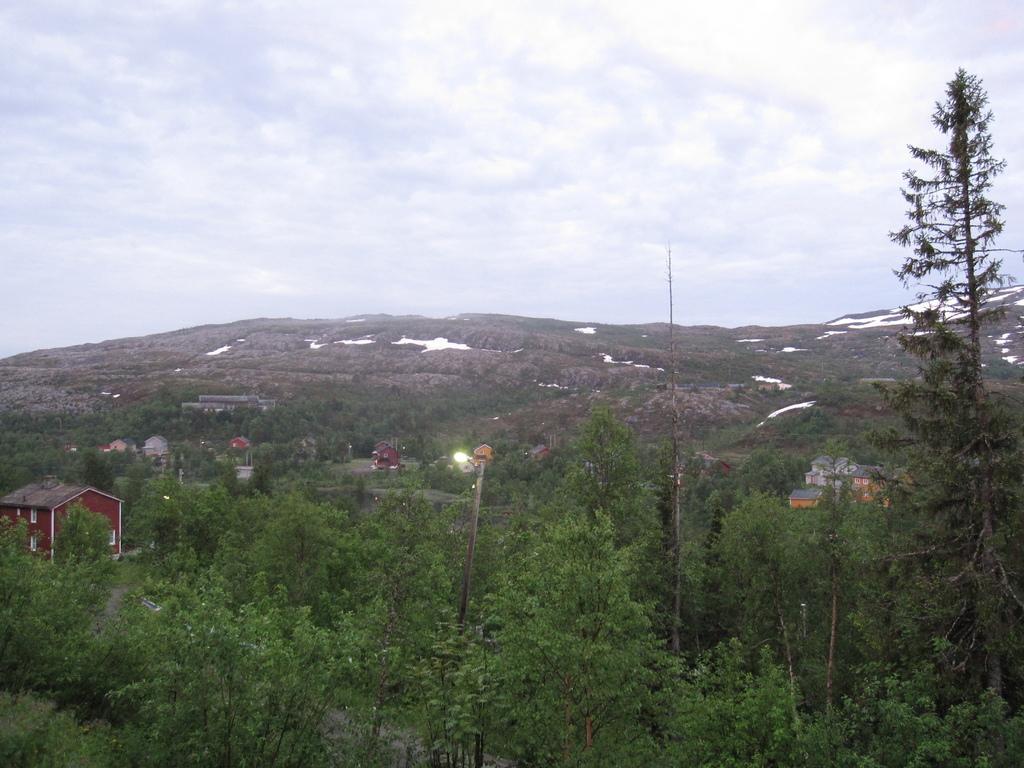How would you summarize this image in a sentence or two? This image is taken outdoors. At the top of the image there is the sky with clouds. In the background there is a hill and it is covered with a little snow. In the middle of the image there are many trees and plants with stems, branches and green leaves. There is a pole with a street light and there are a few houses on the ground. 